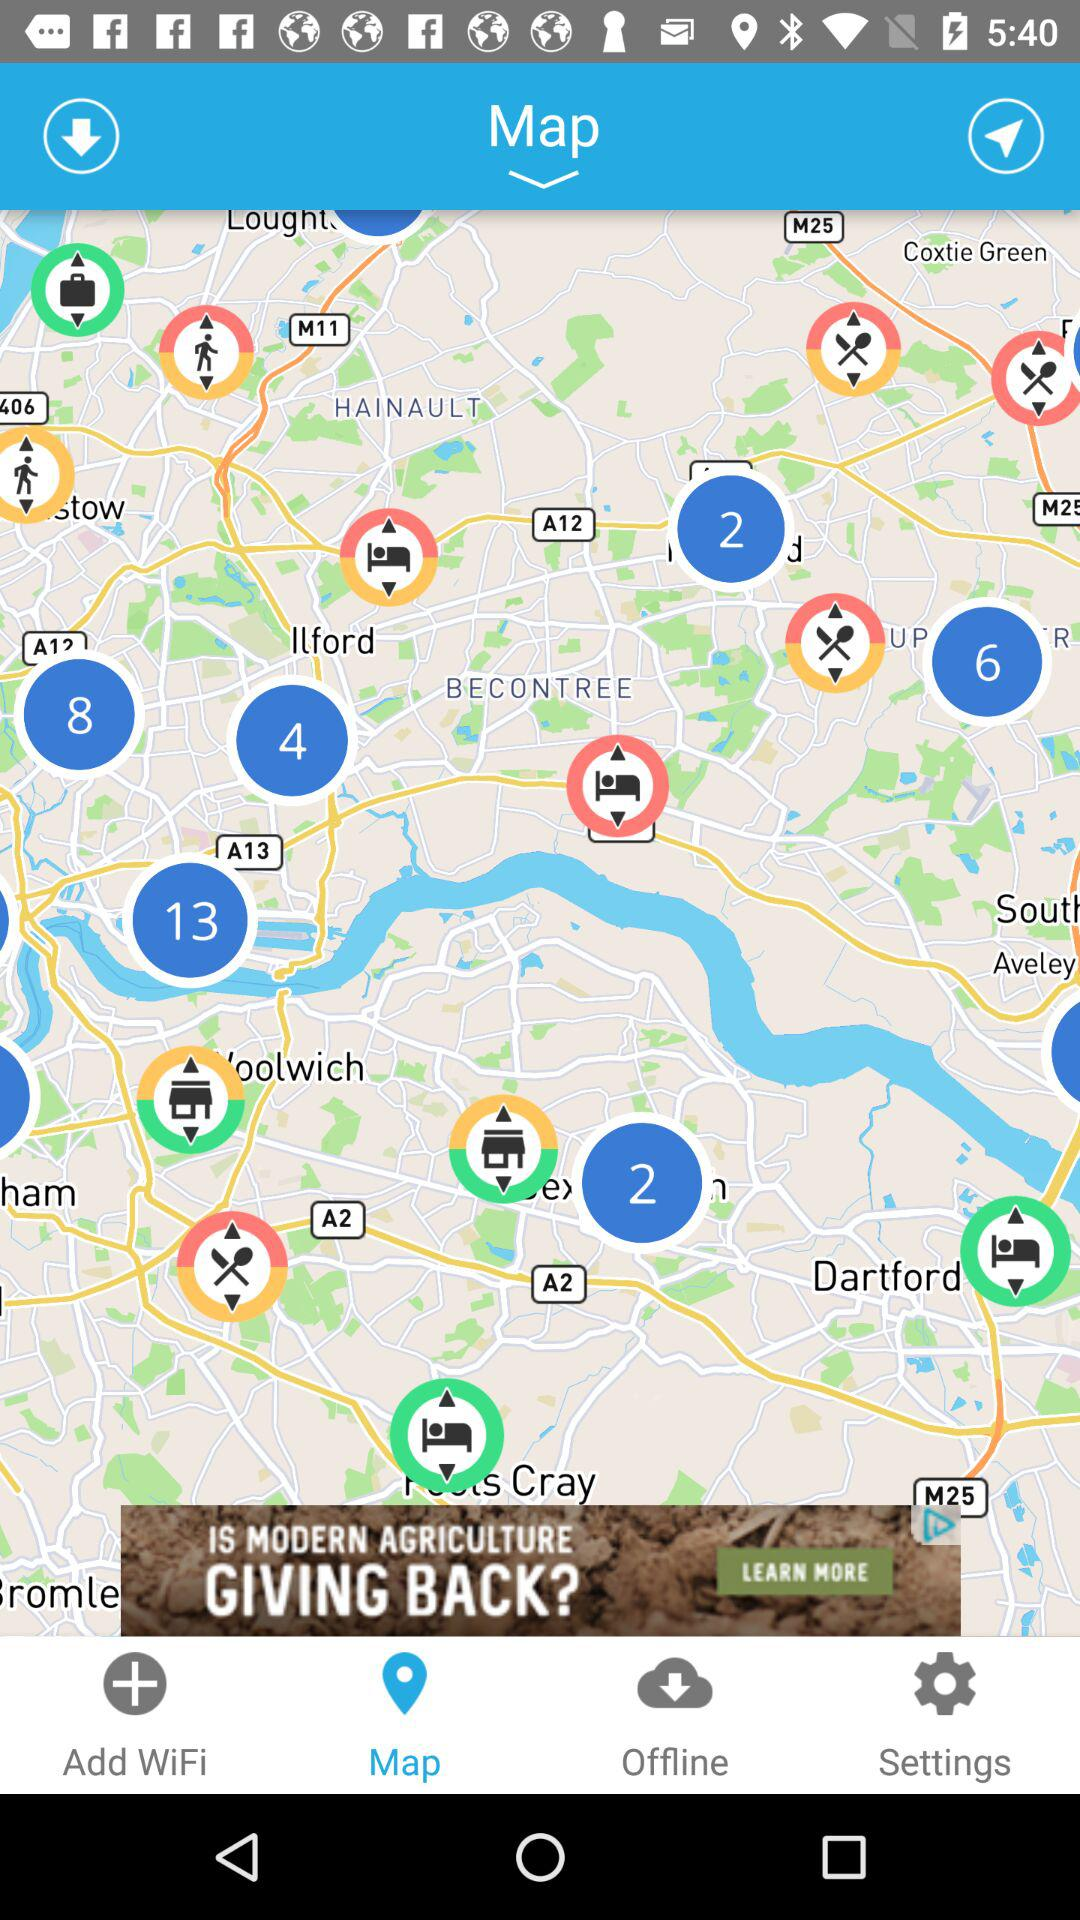Which tab am I using? You are using the "Map" tab. 